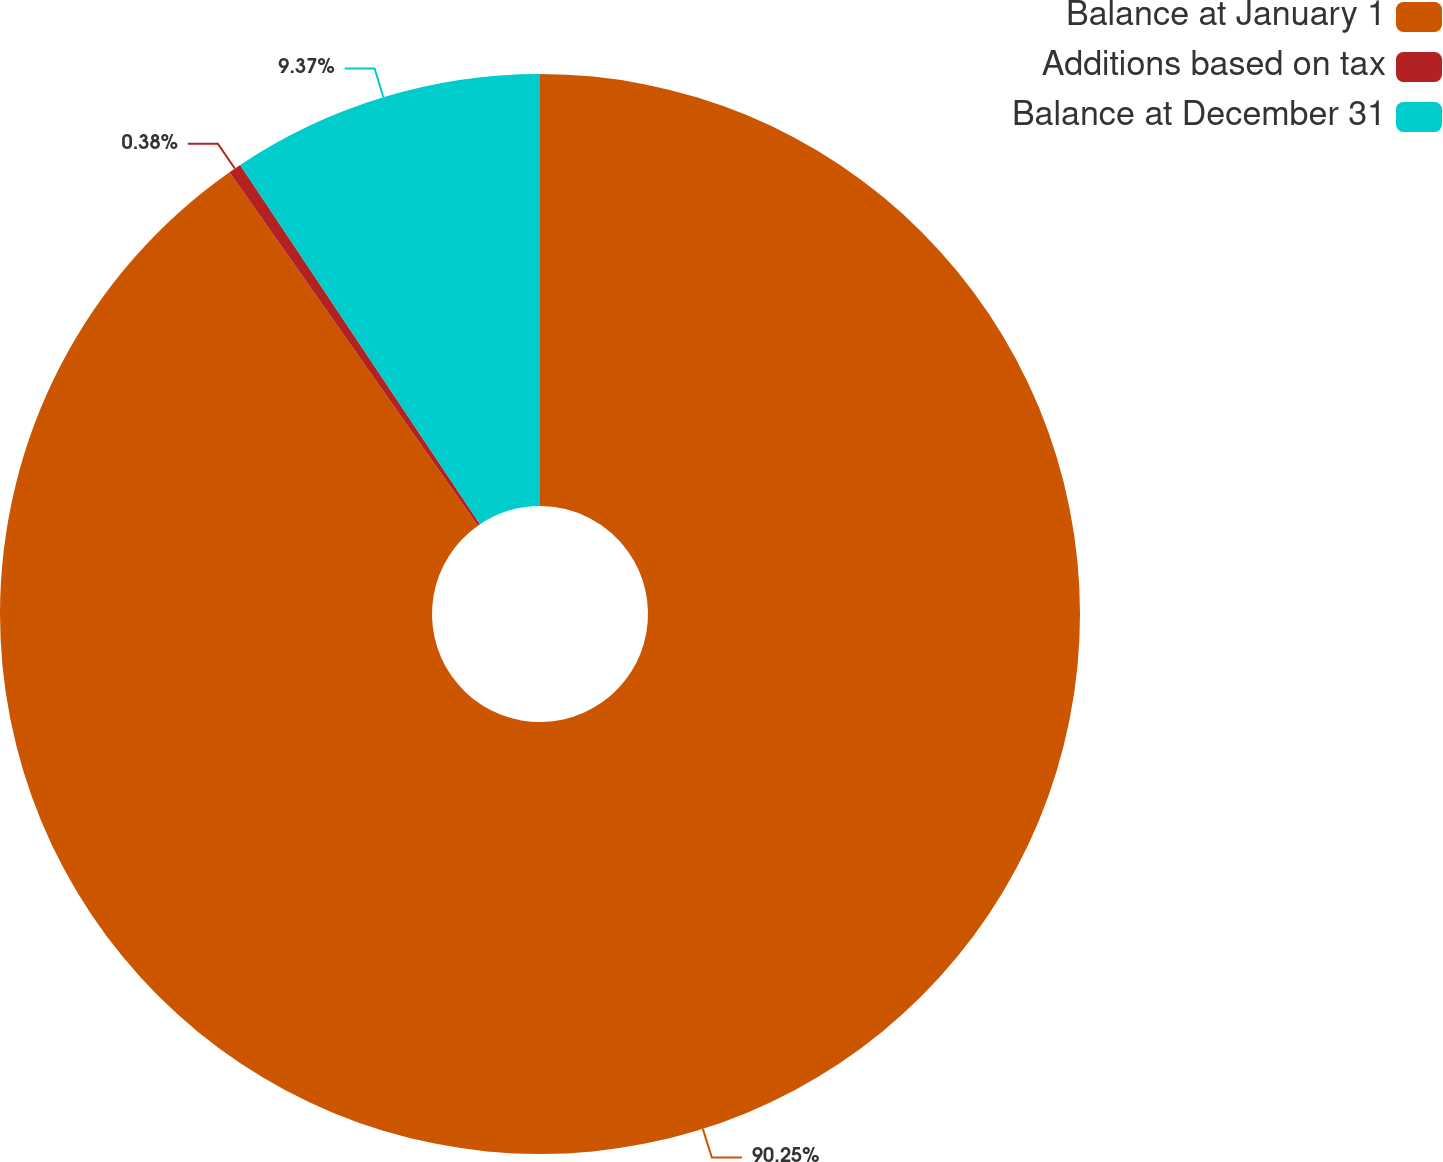Convert chart to OTSL. <chart><loc_0><loc_0><loc_500><loc_500><pie_chart><fcel>Balance at January 1<fcel>Additions based on tax<fcel>Balance at December 31<nl><fcel>90.25%<fcel>0.38%<fcel>9.37%<nl></chart> 